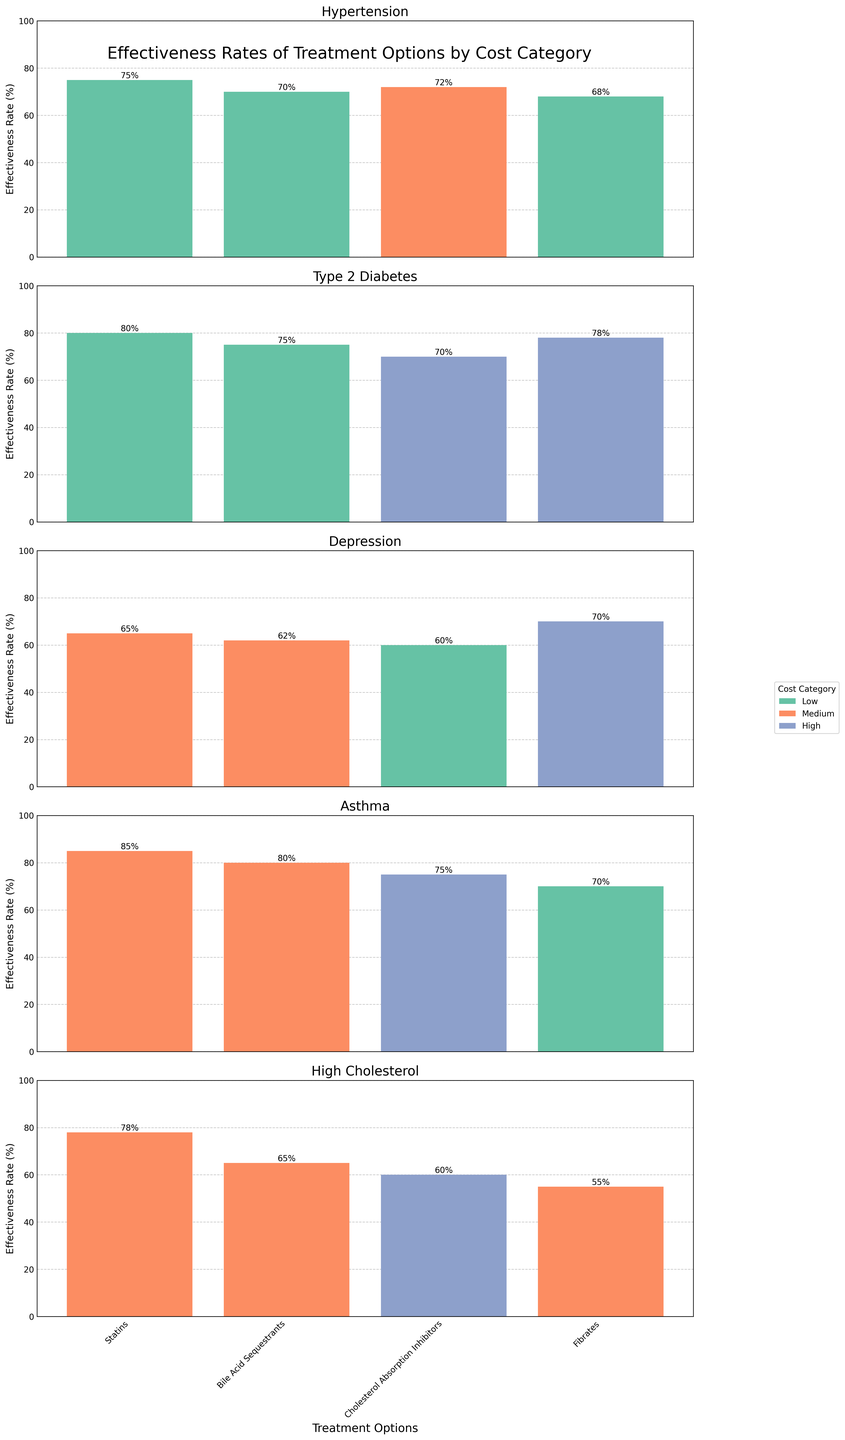Which treatment for Hypertension has the highest effectiveness rate? Look for the tallest bar in the Hypertension category and read its label.
Answer: ACE Inhibitors How do the effectiveness rates of treatments for Type 2 Diabetes compare between Metformin and Sulfonylureas? Compare the heights of the bars for Metformin and Sulfonylureas within the Type 2 Diabetes category.
Answer: Metformin is more effective than Sulfonylureas Which condition has the treatment with the lowest effectiveness rate? Identify the shortest bar in all categories and check its condition label.
Answer: High Cholesterol (Fibrates) What is the average effectiveness rate of treatments for Depression? Add the effectiveness rates of all treatments for Depression and divide by the number of treatments. (65 + 62 + 60 + 70) / 4 = 64.25
Answer: 64.25 Which treatment for Asthma falls under the low-cost category, and what is its effectiveness rate? Look for the bar color representing the low-cost category under Asthma and read its label and height.
Answer: Short-acting Beta Agonists, 70% Compare the highest effectiveness rate treatment for High Cholesterol with the highest effectiveness rate treatment for Type 2 Diabetes. Which one is more effective? Identify the highest bars in both High Cholesterol and Type 2 Diabetes categories and compare their heights.
Answer: Type 2 Diabetes (Metformin, 80%) is more effective than High Cholesterol (Statins, 78%) What is the difference in effectiveness rates between the most and least effective treatments for Asthma? Subtract the effectiveness rate of the least effective treatment in Asthma from the most effective one. 85 - 70 = 15
Answer: 15 How many treatments classified as low-cost have effectiveness rates lower than 70%? Count the bars labeled with low-cost (green) that have heights less than 70%.
Answer: 2 (Diuretics and Tricyclic Antidepressants) Which high-cost treatment has the best effectiveness rate and for which condition? Identify the highest bar labeled with high-cost (purple) and read its treatment and condition labels.
Answer: GLP-1 Receptor Agonists for Type 2 Diabetes What is the sum of effectiveness rates for all medium-cost treatments for High Cholesterol? Add up the effectiveness rates of medium-cost treatments within the High Cholesterol category. 78 + 65 + 55 = 198
Answer: 198 